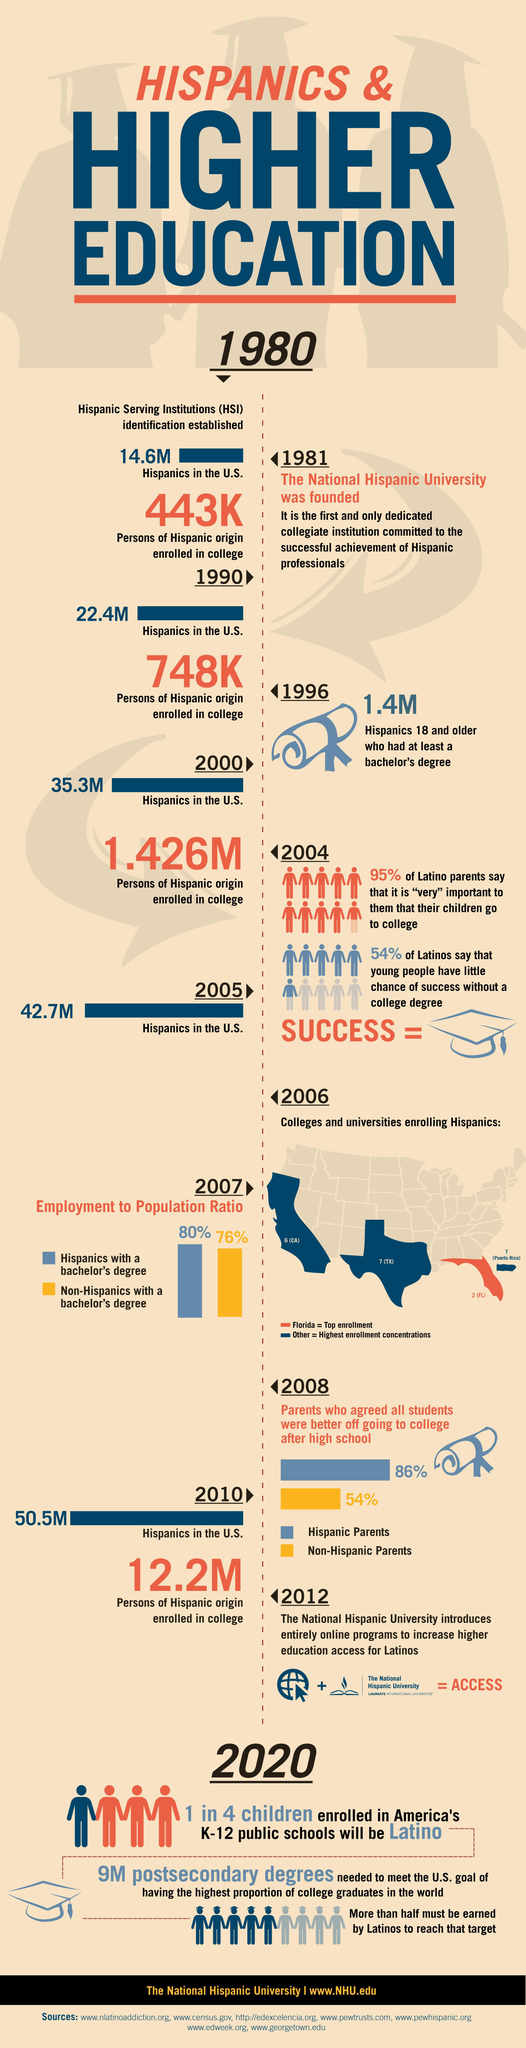Indicate a few pertinent items in this graphic. In 2007, 80% of Hispanics in the United States held a bachelor's degree. In 2008, a significant percentage of Hispanic parents in the United States, at 86%, agreed that all students were better off going to college after high school. In 2005, the population of Hispanics in the United States was estimated to be 42.7 million. In 1996, the population of Hispanics aged 18 and older who had at least a bachelor's degree was 1.4 million. In 1981, the population of Hispanics in the United States was 14.6 million. 